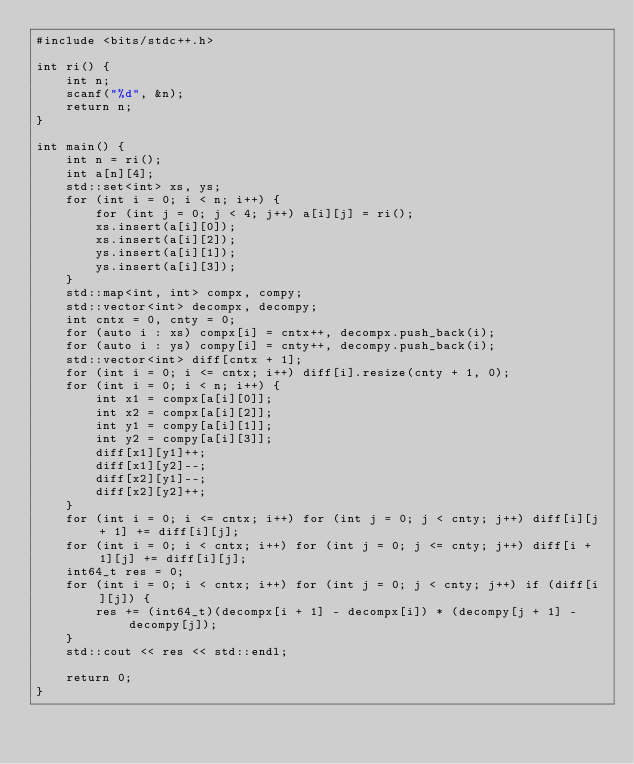Convert code to text. <code><loc_0><loc_0><loc_500><loc_500><_C++_>#include <bits/stdc++.h>

int ri() {
	int n;
	scanf("%d", &n);
	return n;
}

int main() {
	int n = ri();
	int a[n][4];
	std::set<int> xs, ys;
	for (int i = 0; i < n; i++) {
		for (int j = 0; j < 4; j++) a[i][j] = ri();
		xs.insert(a[i][0]);
		xs.insert(a[i][2]);
		ys.insert(a[i][1]);
		ys.insert(a[i][3]);
	}
	std::map<int, int> compx, compy;
	std::vector<int> decompx, decompy;
	int cntx = 0, cnty = 0;
	for (auto i : xs) compx[i] = cntx++, decompx.push_back(i);
	for (auto i : ys) compy[i] = cnty++, decompy.push_back(i);
	std::vector<int> diff[cntx + 1];
	for (int i = 0; i <= cntx; i++) diff[i].resize(cnty + 1, 0);
	for (int i = 0; i < n; i++) {
		int x1 = compx[a[i][0]];
		int x2 = compx[a[i][2]];
		int y1 = compy[a[i][1]];
		int y2 = compy[a[i][3]];
		diff[x1][y1]++;
		diff[x1][y2]--;
		diff[x2][y1]--;
		diff[x2][y2]++;
	}
	for (int i = 0; i <= cntx; i++) for (int j = 0; j < cnty; j++) diff[i][j + 1] += diff[i][j];
	for (int i = 0; i < cntx; i++) for (int j = 0; j <= cnty; j++) diff[i + 1][j] += diff[i][j];
	int64_t res = 0;
	for (int i = 0; i < cntx; i++) for (int j = 0; j < cnty; j++) if (diff[i][j]) {
		res += (int64_t)(decompx[i + 1] - decompx[i]) * (decompy[j + 1] - decompy[j]);
	}
	std::cout << res << std::endl;
	
	return 0;
}

</code> 